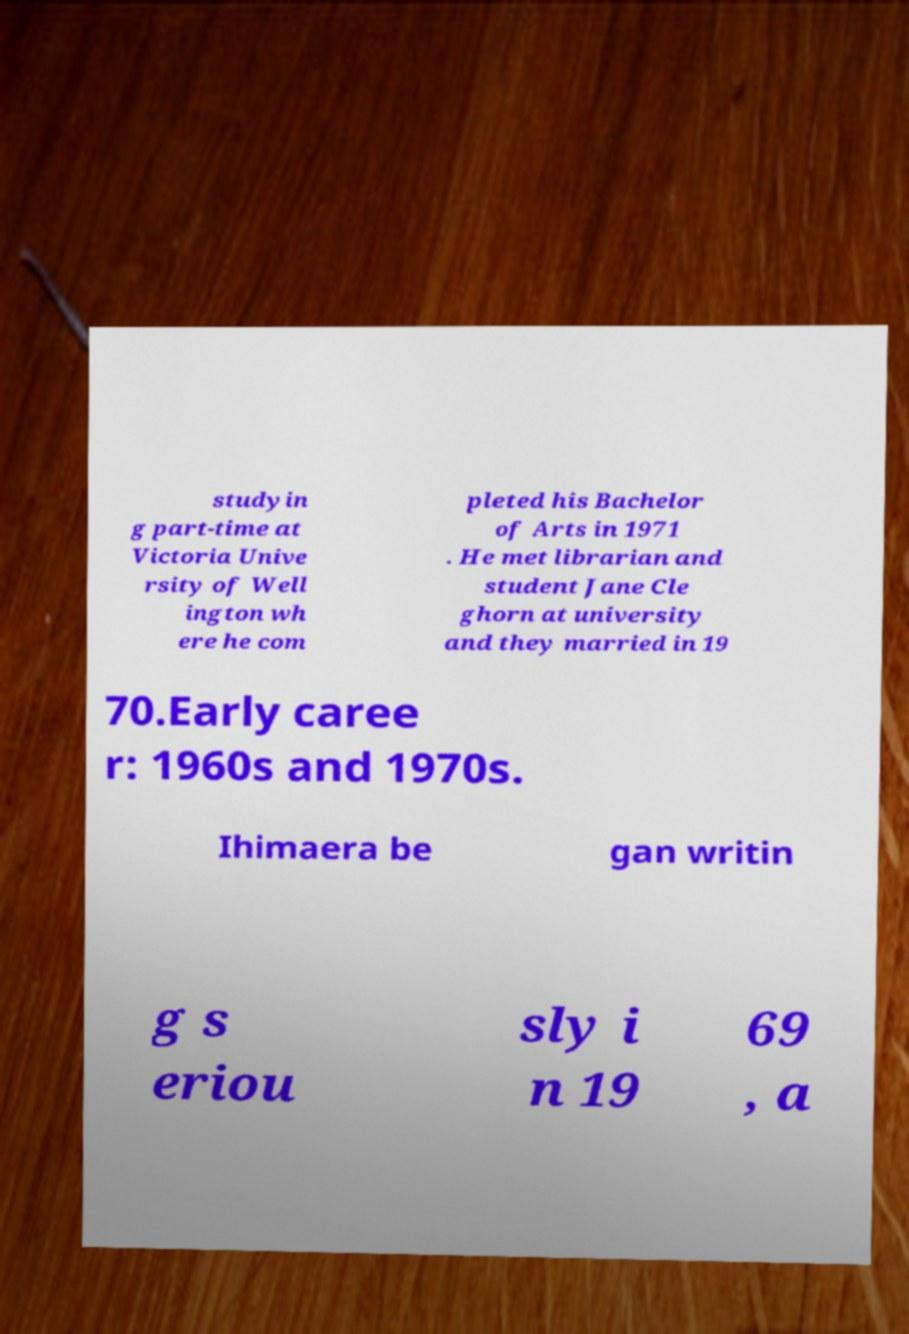What messages or text are displayed in this image? I need them in a readable, typed format. studyin g part-time at Victoria Unive rsity of Well ington wh ere he com pleted his Bachelor of Arts in 1971 . He met librarian and student Jane Cle ghorn at university and they married in 19 70.Early caree r: 1960s and 1970s. Ihimaera be gan writin g s eriou sly i n 19 69 , a 